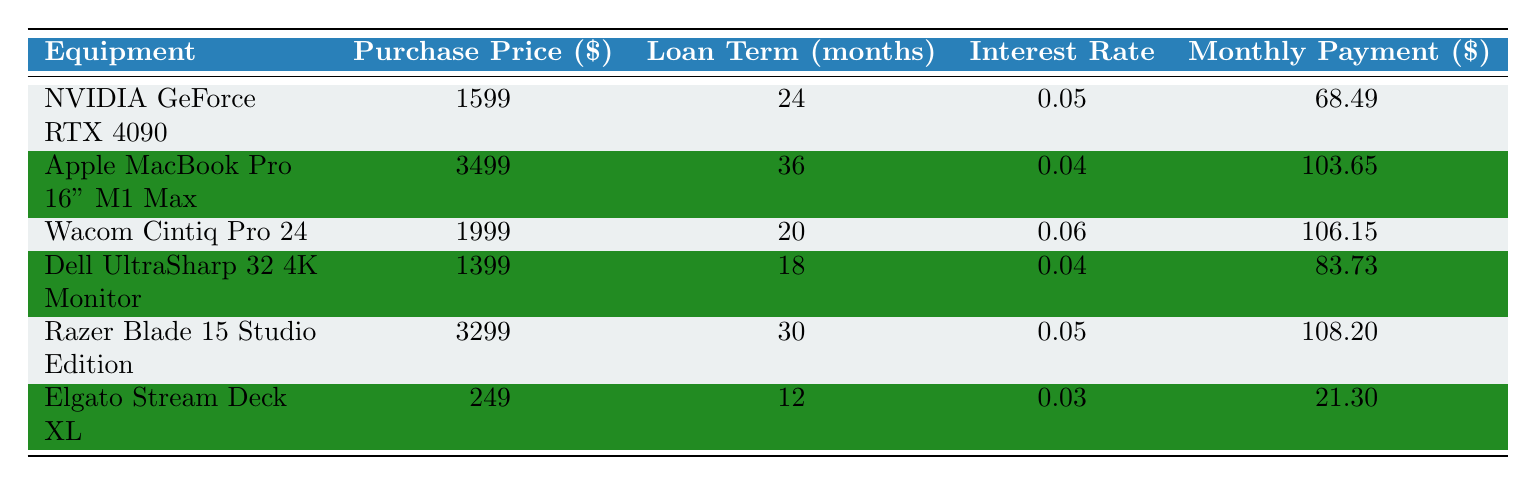What is the purchase price of the Wacom Cintiq Pro 24? The table lists the Wacom Cintiq Pro 24 under the "Equipment" column, and the corresponding purchase price is $1999.
Answer: 1999 What is the monthly payment for the Apple MacBook Pro 16" M1 Max? By looking at the row for the Apple MacBook Pro 16" M1 Max, the table states that the monthly payment is $103.65.
Answer: 103.65 Which equipment has the highest interest rate? To find the highest interest rate, we can compare the rates listed for each equipment: 0.05, 0.04, 0.06, 0.04, 0.05, and 0.03. The highest is 0.06 for the Wacom Cintiq Pro 24.
Answer: Wacom Cintiq Pro 24 What is the total purchase price of all items listed? The total purchase price is calculated by summing all the purchase prices: $1599 + $3499 + $1999 + $1399 + $3299 + $249 = $12944.
Answer: 12944 Is the monthly payment for the Elgato Stream Deck XL less than $25? The table shows that the monthly payment for the Elgato Stream Deck XL is $21.30, which is less than $25.
Answer: Yes How many months will it take to pay off the Razer Blade 15 Studio Edition and Dell UltraSharp 32 4K Monitor combined? The Razer Blade 15 Studio Edition has a loan term of 30 months, and the Dell UltraSharp 32 4K Monitor has a loan term of 18 months. Adding these together gives us 30 + 18 = 48 months.
Answer: 48 What is the average monthly payment for all items in the list? The monthly payments for the items are $68.49, $103.65, $106.15, $83.73, $108.20, and $21.30. Summing these gives $491.72, and dividing by 6 (the number of items) results in an average monthly payment of $81.95.
Answer: 81.95 Which item has the lowest monthly payment? Looking at the monthly payments, the Elgato Stream Deck XL has the lowest monthly payment at $21.30.
Answer: Elgato Stream Deck XL Is the total of the loan terms for all equipment greater than 100 months? Summing the loan terms gives us 24 + 36 + 20 + 18 + 30 + 12 = 150 months, which is greater than 100.
Answer: Yes 